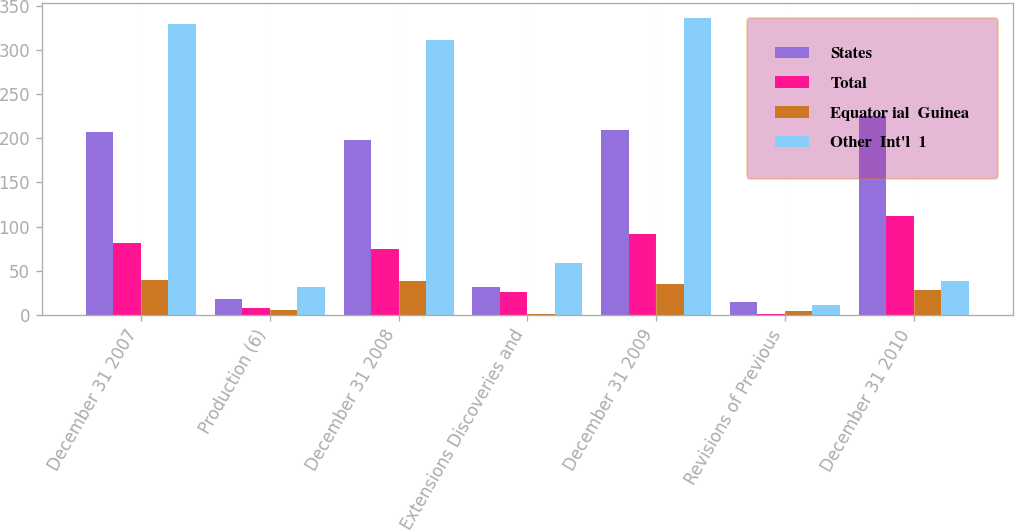<chart> <loc_0><loc_0><loc_500><loc_500><stacked_bar_chart><ecel><fcel>December 31 2007<fcel>Production (6)<fcel>December 31 2008<fcel>Extensions Discoveries and<fcel>December 31 2009<fcel>Revisions of Previous<fcel>December 31 2010<nl><fcel>States<fcel>207<fcel>18<fcel>198<fcel>32<fcel>209<fcel>15<fcel>225<nl><fcel>Total<fcel>82<fcel>8<fcel>75<fcel>26<fcel>92<fcel>1<fcel>112<nl><fcel>Equator ial  Guinea<fcel>40<fcel>6<fcel>38<fcel>1<fcel>35<fcel>5<fcel>28<nl><fcel>Other  Int'l  1<fcel>329<fcel>32<fcel>311<fcel>59<fcel>336<fcel>11<fcel>38<nl></chart> 